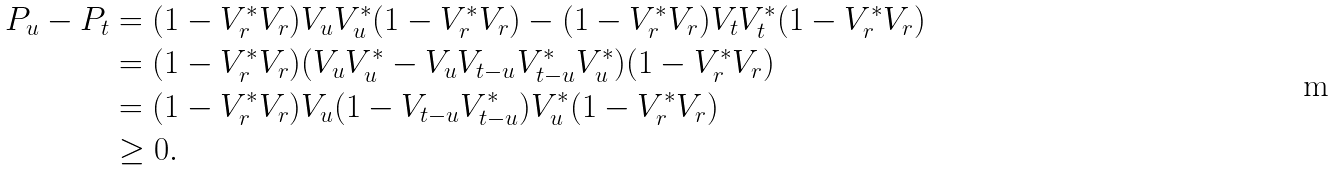<formula> <loc_0><loc_0><loc_500><loc_500>P _ { u } - P _ { t } & = ( 1 - V _ { r } ^ { * } V _ { r } ) V _ { u } V _ { u } ^ { * } ( 1 - V _ { r } ^ { * } V _ { r } ) - ( 1 - V _ { r } ^ { * } V _ { r } ) V _ { t } V _ { t } ^ { * } ( 1 - V _ { r } ^ { * } V _ { r } ) \\ & = ( 1 - V _ { r } ^ { * } V _ { r } ) ( V _ { u } V _ { u } ^ { * } - V _ { u } V _ { t - u } V _ { t - u } ^ { * } V _ { u } ^ { * } ) ( 1 - V _ { r } ^ { * } V _ { r } ) \\ & = ( 1 - V _ { r } ^ { * } V _ { r } ) V _ { u } ( 1 - V _ { t - u } V _ { t - u } ^ { * } ) V _ { u } ^ { * } ( 1 - V _ { r } ^ { * } V _ { r } ) \\ & \geq 0 .</formula> 